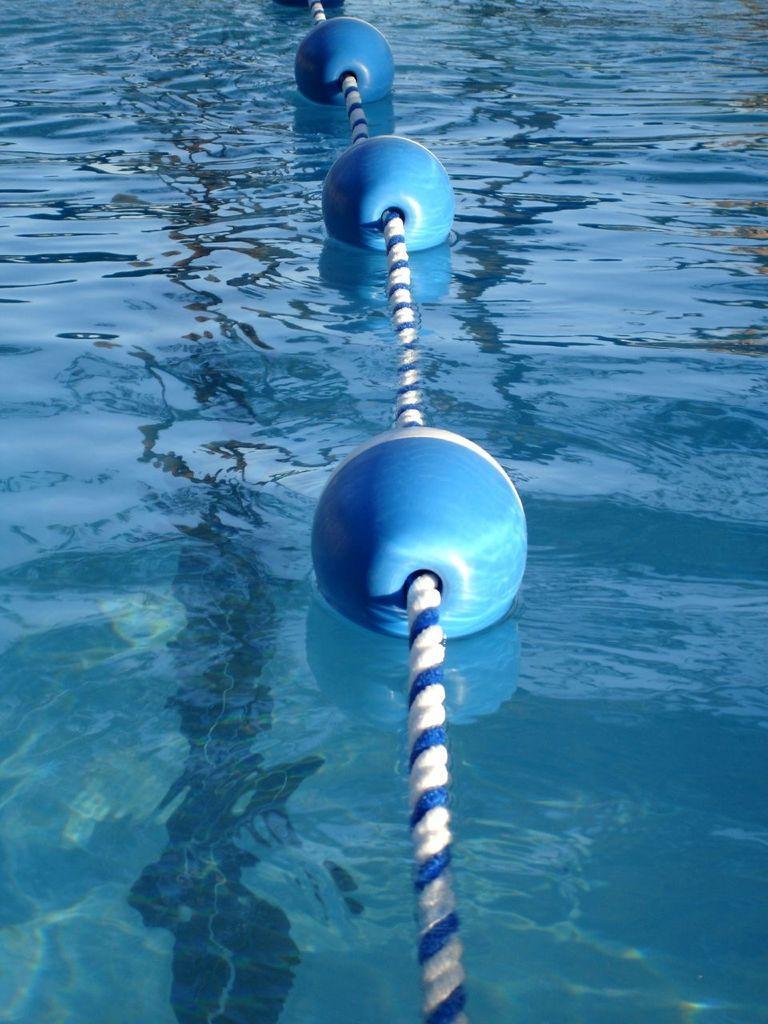Can you describe this image briefly? In this picture we can see floating balls are attached with rope on water. 